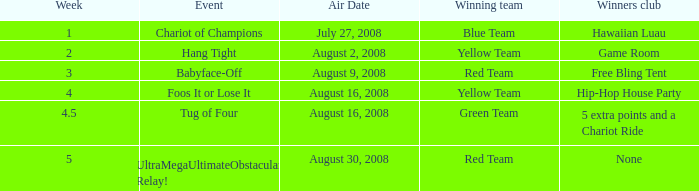Which Winners club has an Event of hang tight? Game Room. 